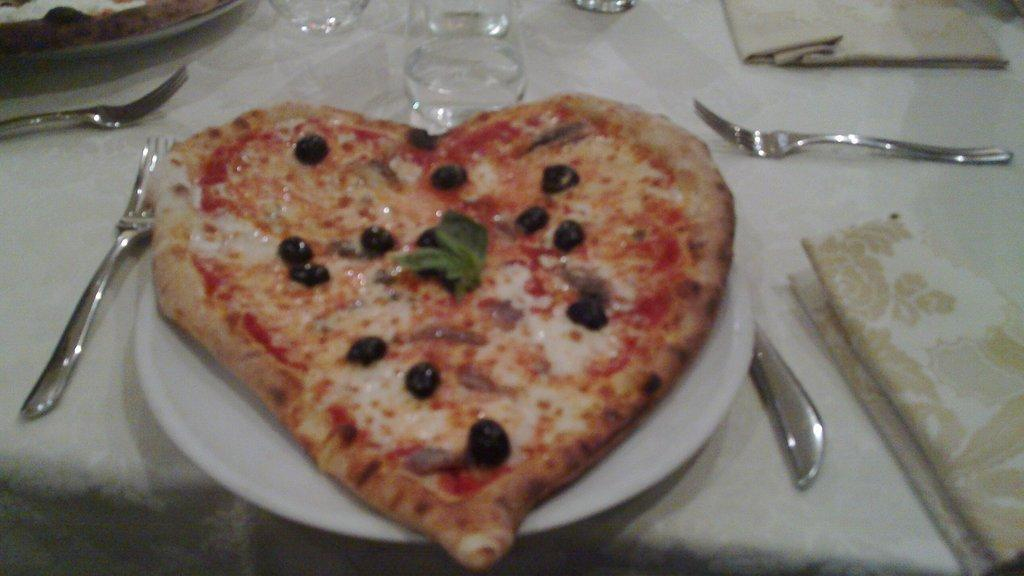What type of food is depicted in the image? The food in the image resembles pizza. How is the food arranged in the image? The food is on a plate. What utensils are present on the table in the image? There are forks on the table. What is the color of the table in the image? The table is white. How many bricks are stacked on the plate in the image? There are no bricks present in the image; it features food that resembles pizza on a plate. What role does the actor play in the image? There is no actor present in the image; it is a still image of food on a plate. 